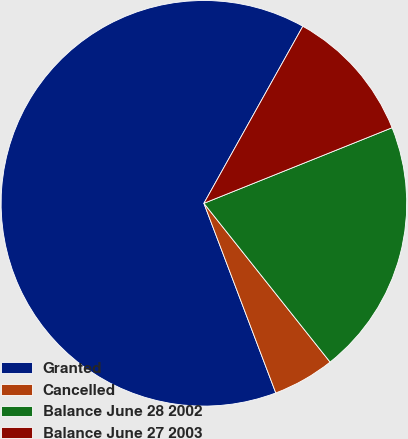Convert chart. <chart><loc_0><loc_0><loc_500><loc_500><pie_chart><fcel>Granted<fcel>Cancelled<fcel>Balance June 28 2002<fcel>Balance June 27 2003<nl><fcel>63.87%<fcel>4.92%<fcel>20.39%<fcel>10.81%<nl></chart> 